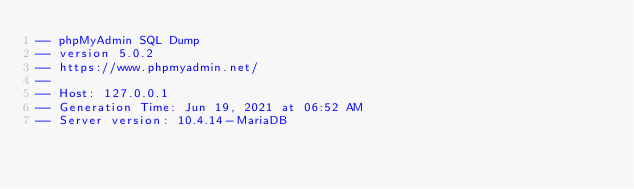Convert code to text. <code><loc_0><loc_0><loc_500><loc_500><_SQL_>-- phpMyAdmin SQL Dump
-- version 5.0.2
-- https://www.phpmyadmin.net/
--
-- Host: 127.0.0.1
-- Generation Time: Jun 19, 2021 at 06:52 AM
-- Server version: 10.4.14-MariaDB</code> 